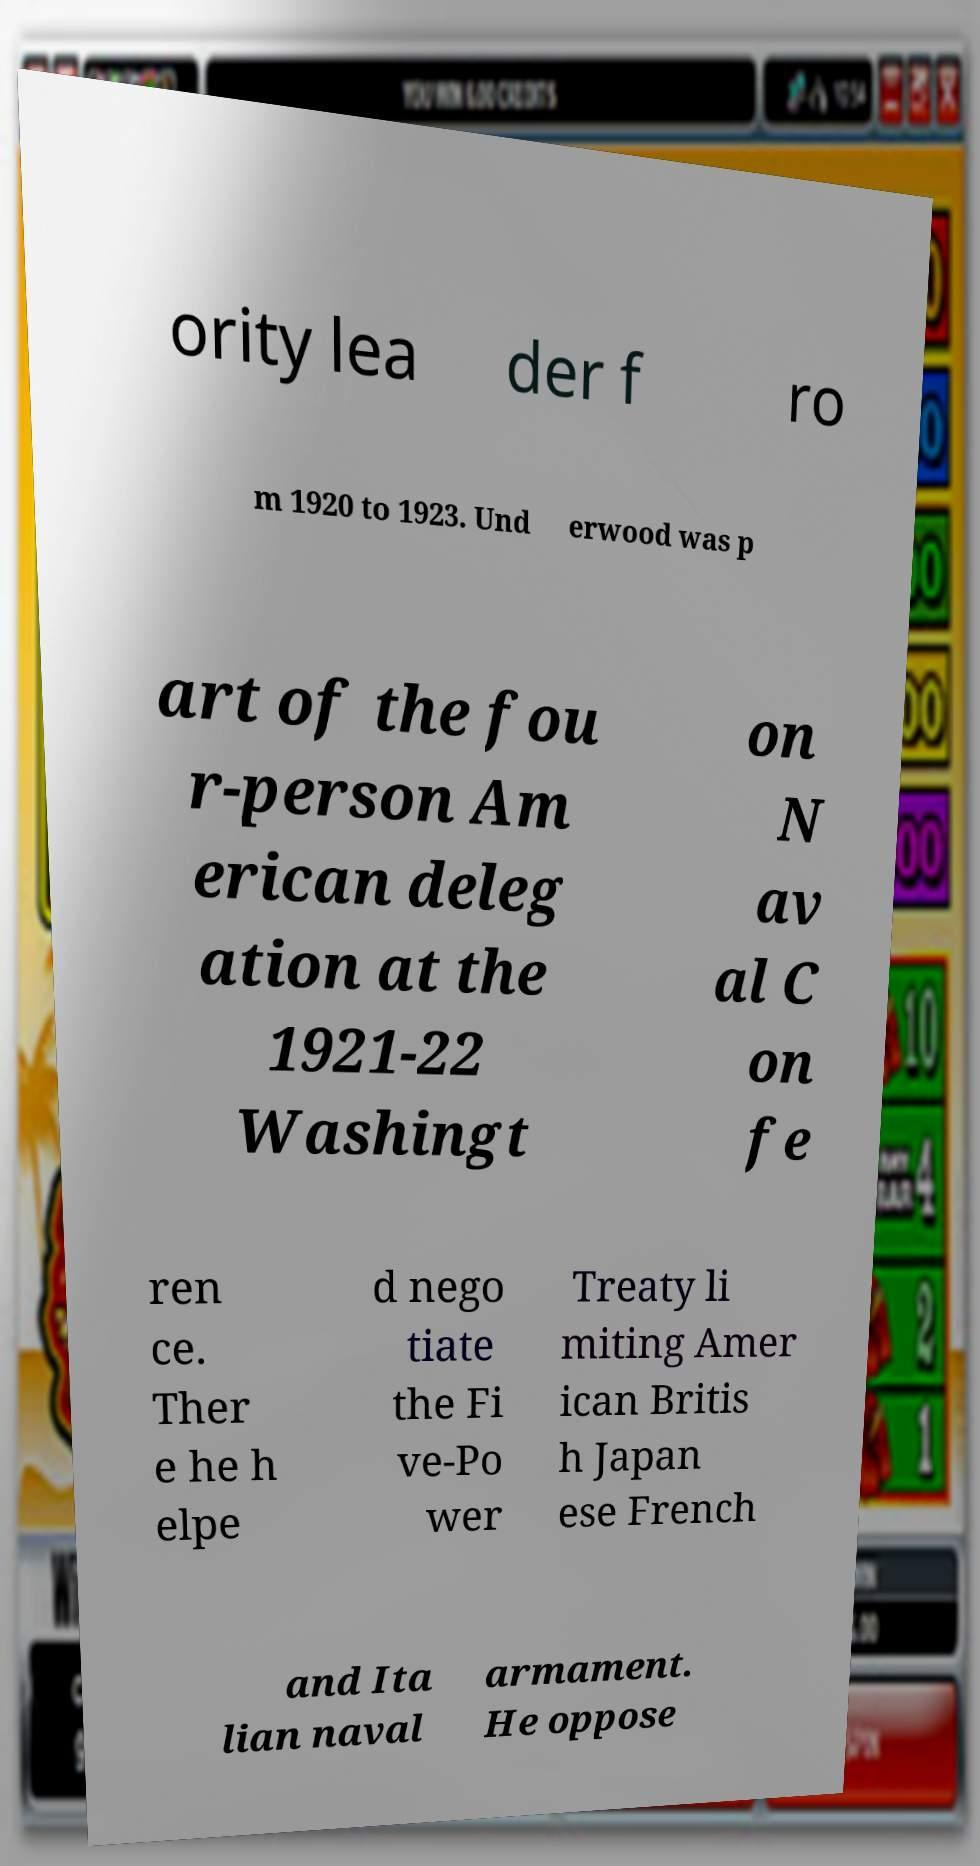Please identify and transcribe the text found in this image. ority lea der f ro m 1920 to 1923. Und erwood was p art of the fou r-person Am erican deleg ation at the 1921-22 Washingt on N av al C on fe ren ce. Ther e he h elpe d nego tiate the Fi ve-Po wer Treaty li miting Amer ican Britis h Japan ese French and Ita lian naval armament. He oppose 